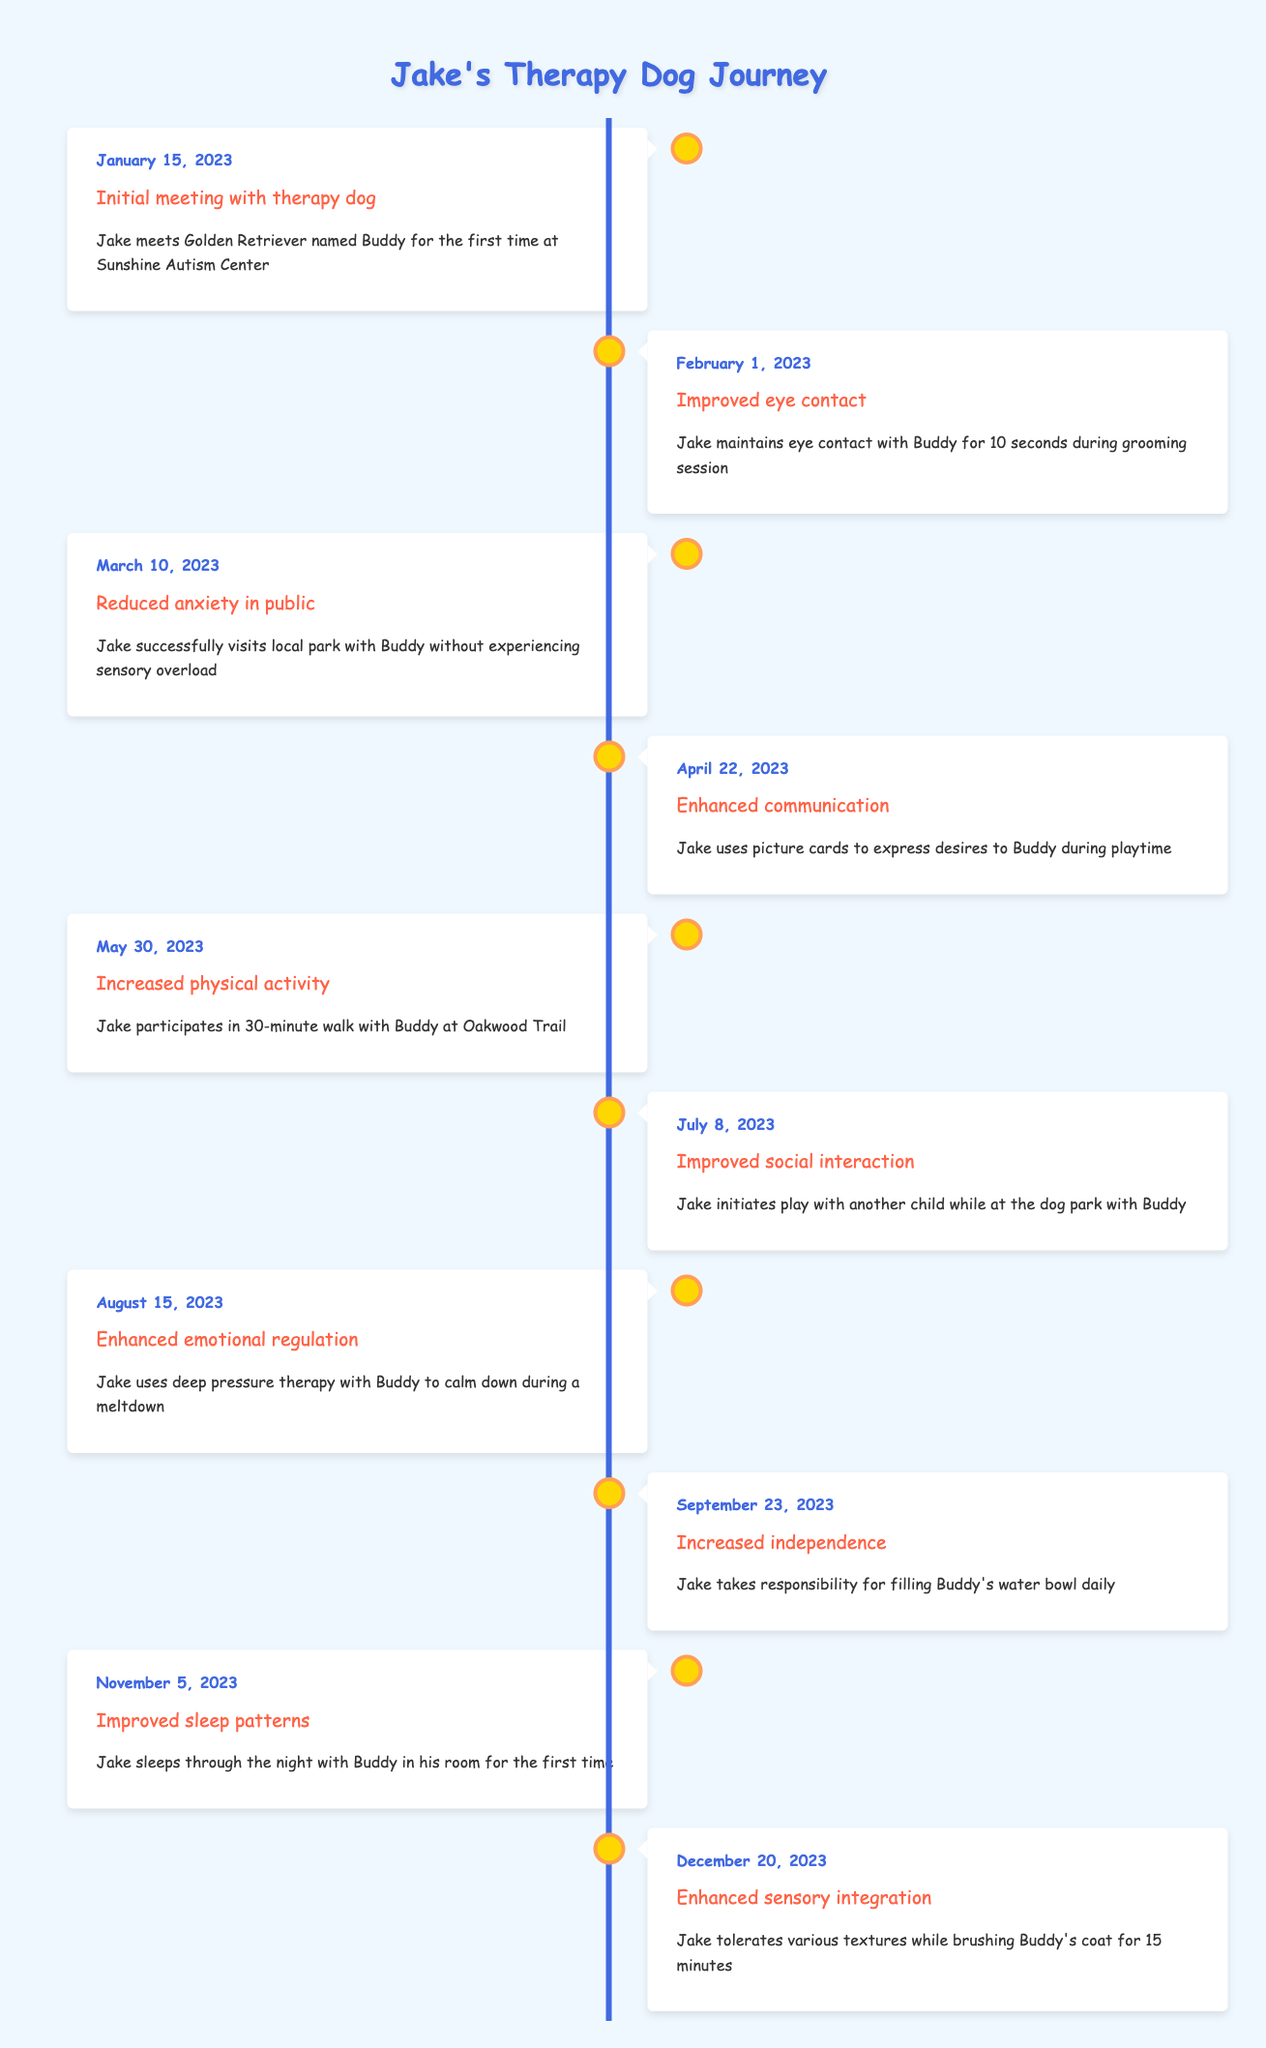What was the first milestone Jake achieved with Buddy? The first milestone listed in the timeline is "Initial meeting with therapy dog," which occurred on January 15, 2023.
Answer: Initial meeting with therapy dog On what date did Jake show improved eye contact? The timeline indicates that Jake improved eye contact on February 1, 2023, during a grooming session with Buddy.
Answer: February 1, 2023 Did Jake experience reduced anxiety in public before or after he improved his social interaction? Jake experienced reduced anxiety in public on March 10, 2023, while he improved social interaction on July 8, 2023. Since March comes before July, he reduced anxiety first.
Answer: Before What milestone occurred exactly five months after the initial meeting? The initial meeting was on January 15, 2023. Counting five months ahead lands on June 15, 2023, which does not have a milestone designated in the table. Therefore, the next milestone afterward is "Improved social interaction" on July 8, 2023.
Answer: Improved social interaction How many milestones are listed between enhanced communication and improved sleep patterns? Enhanced communication is marked on April 22, 2023, and improved sleep patterns is on November 5, 2023. The milestones listed between these dates are: "Increased physical activity" (May 30), "Improved social interaction" (July 8), and "Enhanced emotional regulation" (August 15). That is a total of three milestones.
Answer: 3 Is it true that Jake has shown improvements in both emotional regulation and sensory integration? Yes, the timeline shows that Jake enhanced emotional regulation on August 15, 2023, and enhanced sensory integration on December 20, 2023, confirming that both improvements occurred.
Answer: Yes What was Jake's responsibility towards Buddy on September 23, 2023? On September 23, 2023, Jake took responsibility for filling Buddy's water bowl daily, which is documented as a milestone in the timeline.
Answer: Filling Buddy's water bowl daily How many weeks are there between Jake's improved sleep patterns and enhanced sensory integration? Improved sleep patterns occurred on November 5, 2023, and enhanced sensory integration was on December 20, 2023. From November 5 to December 5 is 4 weeks, and from December 5 to December 20 is an additional 2 weeks, totaling 6 weeks.
Answer: 6 weeks What percentage of the milestones focus on emotional and social development? There are 10 milestones total. The milestones focusing on emotional and social development are: "Improved eye contact," "Reduced anxiety in public," "Enhanced communication," "Improved social interaction," and "Enhanced emotional regulation." That accounts for 5 out of 10 milestones, which is 50%.
Answer: 50% 